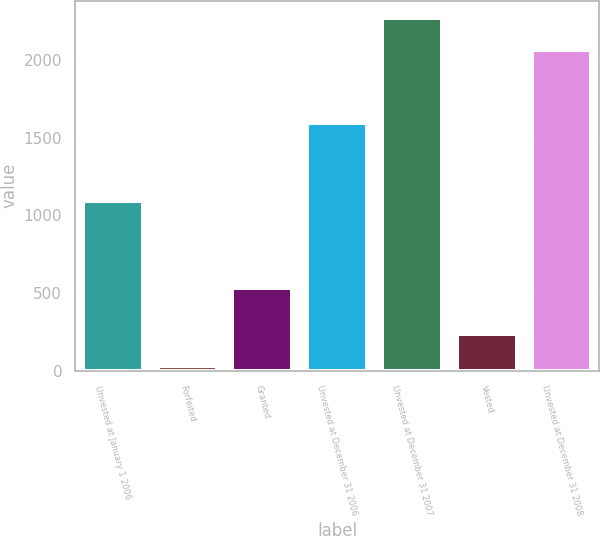Convert chart to OTSL. <chart><loc_0><loc_0><loc_500><loc_500><bar_chart><fcel>Unvested at January 1 2006<fcel>Forfeited<fcel>Granted<fcel>Unvested at December 31 2006<fcel>Unvested at December 31 2007<fcel>Vested<fcel>Unvested at December 31 2008<nl><fcel>1091<fcel>30<fcel>536<fcel>1597<fcel>2269.1<fcel>235.1<fcel>2064<nl></chart> 